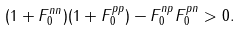<formula> <loc_0><loc_0><loc_500><loc_500>( 1 + F _ { 0 } ^ { n n } ) ( 1 + F _ { 0 } ^ { p p } ) - F _ { 0 } ^ { n p } F _ { 0 } ^ { p n } > 0 .</formula> 